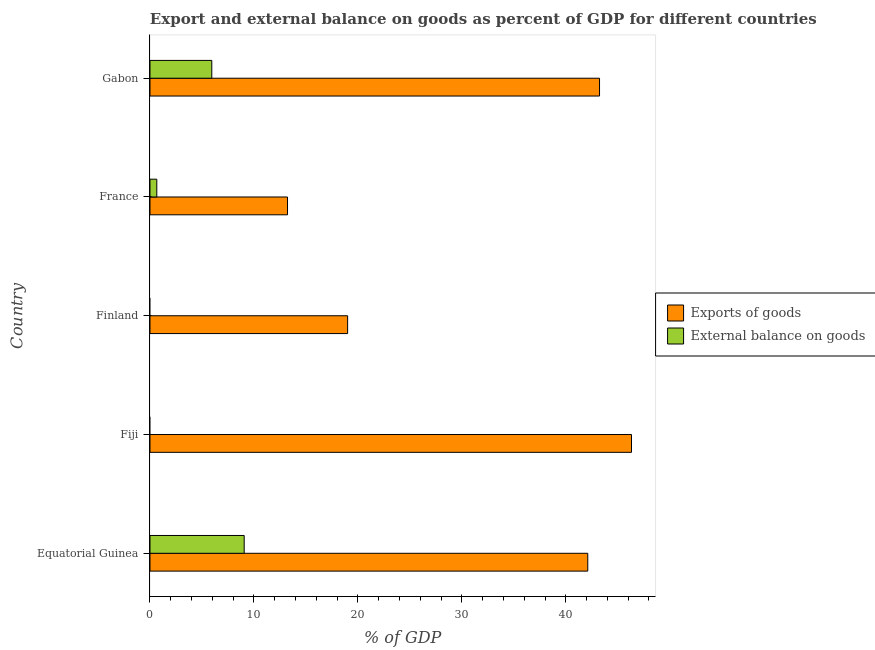How many different coloured bars are there?
Ensure brevity in your answer.  2. Are the number of bars per tick equal to the number of legend labels?
Make the answer very short. No. Are the number of bars on each tick of the Y-axis equal?
Ensure brevity in your answer.  No. What is the label of the 1st group of bars from the top?
Provide a short and direct response. Gabon. What is the export of goods as percentage of gdp in Equatorial Guinea?
Your answer should be very brief. 42.11. Across all countries, what is the maximum export of goods as percentage of gdp?
Give a very brief answer. 46.32. Across all countries, what is the minimum export of goods as percentage of gdp?
Your answer should be compact. 13.23. In which country was the export of goods as percentage of gdp maximum?
Make the answer very short. Fiji. What is the total export of goods as percentage of gdp in the graph?
Give a very brief answer. 163.91. What is the difference between the external balance on goods as percentage of gdp in Equatorial Guinea and that in France?
Keep it short and to the point. 8.41. What is the difference between the external balance on goods as percentage of gdp in Fiji and the export of goods as percentage of gdp in Finland?
Keep it short and to the point. -19.01. What is the average export of goods as percentage of gdp per country?
Provide a short and direct response. 32.78. What is the difference between the external balance on goods as percentage of gdp and export of goods as percentage of gdp in Equatorial Guinea?
Keep it short and to the point. -33.05. What is the ratio of the export of goods as percentage of gdp in Fiji to that in Gabon?
Ensure brevity in your answer.  1.07. What is the difference between the highest and the second highest export of goods as percentage of gdp?
Give a very brief answer. 3.08. What is the difference between the highest and the lowest external balance on goods as percentage of gdp?
Your answer should be compact. 9.06. In how many countries, is the external balance on goods as percentage of gdp greater than the average external balance on goods as percentage of gdp taken over all countries?
Provide a short and direct response. 2. Is the sum of the export of goods as percentage of gdp in Fiji and Finland greater than the maximum external balance on goods as percentage of gdp across all countries?
Give a very brief answer. Yes. How many bars are there?
Give a very brief answer. 8. Does the graph contain any zero values?
Make the answer very short. Yes. How are the legend labels stacked?
Offer a very short reply. Vertical. What is the title of the graph?
Offer a terse response. Export and external balance on goods as percent of GDP for different countries. What is the label or title of the X-axis?
Offer a very short reply. % of GDP. What is the % of GDP in Exports of goods in Equatorial Guinea?
Ensure brevity in your answer.  42.11. What is the % of GDP in External balance on goods in Equatorial Guinea?
Keep it short and to the point. 9.06. What is the % of GDP of Exports of goods in Fiji?
Make the answer very short. 46.32. What is the % of GDP in Exports of goods in Finland?
Ensure brevity in your answer.  19.01. What is the % of GDP in Exports of goods in France?
Keep it short and to the point. 13.23. What is the % of GDP of External balance on goods in France?
Offer a terse response. 0.66. What is the % of GDP of Exports of goods in Gabon?
Offer a terse response. 43.24. What is the % of GDP in External balance on goods in Gabon?
Offer a terse response. 5.95. Across all countries, what is the maximum % of GDP of Exports of goods?
Offer a very short reply. 46.32. Across all countries, what is the maximum % of GDP in External balance on goods?
Keep it short and to the point. 9.06. Across all countries, what is the minimum % of GDP in Exports of goods?
Provide a succinct answer. 13.23. What is the total % of GDP in Exports of goods in the graph?
Your answer should be compact. 163.91. What is the total % of GDP in External balance on goods in the graph?
Provide a succinct answer. 15.66. What is the difference between the % of GDP in Exports of goods in Equatorial Guinea and that in Fiji?
Offer a terse response. -4.21. What is the difference between the % of GDP in Exports of goods in Equatorial Guinea and that in Finland?
Make the answer very short. 23.1. What is the difference between the % of GDP in Exports of goods in Equatorial Guinea and that in France?
Your response must be concise. 28.88. What is the difference between the % of GDP of External balance on goods in Equatorial Guinea and that in France?
Make the answer very short. 8.41. What is the difference between the % of GDP of Exports of goods in Equatorial Guinea and that in Gabon?
Your response must be concise. -1.13. What is the difference between the % of GDP of External balance on goods in Equatorial Guinea and that in Gabon?
Provide a short and direct response. 3.11. What is the difference between the % of GDP of Exports of goods in Fiji and that in Finland?
Make the answer very short. 27.31. What is the difference between the % of GDP of Exports of goods in Fiji and that in France?
Keep it short and to the point. 33.09. What is the difference between the % of GDP of Exports of goods in Fiji and that in Gabon?
Keep it short and to the point. 3.08. What is the difference between the % of GDP of Exports of goods in Finland and that in France?
Give a very brief answer. 5.78. What is the difference between the % of GDP in Exports of goods in Finland and that in Gabon?
Offer a terse response. -24.23. What is the difference between the % of GDP of Exports of goods in France and that in Gabon?
Your answer should be compact. -30.01. What is the difference between the % of GDP of External balance on goods in France and that in Gabon?
Your response must be concise. -5.29. What is the difference between the % of GDP in Exports of goods in Equatorial Guinea and the % of GDP in External balance on goods in France?
Your answer should be very brief. 41.46. What is the difference between the % of GDP of Exports of goods in Equatorial Guinea and the % of GDP of External balance on goods in Gabon?
Offer a terse response. 36.17. What is the difference between the % of GDP of Exports of goods in Fiji and the % of GDP of External balance on goods in France?
Provide a succinct answer. 45.66. What is the difference between the % of GDP in Exports of goods in Fiji and the % of GDP in External balance on goods in Gabon?
Your answer should be compact. 40.37. What is the difference between the % of GDP of Exports of goods in Finland and the % of GDP of External balance on goods in France?
Your answer should be compact. 18.36. What is the difference between the % of GDP of Exports of goods in Finland and the % of GDP of External balance on goods in Gabon?
Make the answer very short. 13.07. What is the difference between the % of GDP of Exports of goods in France and the % of GDP of External balance on goods in Gabon?
Ensure brevity in your answer.  7.28. What is the average % of GDP in Exports of goods per country?
Make the answer very short. 32.78. What is the average % of GDP in External balance on goods per country?
Your answer should be compact. 3.13. What is the difference between the % of GDP of Exports of goods and % of GDP of External balance on goods in Equatorial Guinea?
Make the answer very short. 33.05. What is the difference between the % of GDP in Exports of goods and % of GDP in External balance on goods in France?
Make the answer very short. 12.57. What is the difference between the % of GDP in Exports of goods and % of GDP in External balance on goods in Gabon?
Offer a very short reply. 37.3. What is the ratio of the % of GDP of Exports of goods in Equatorial Guinea to that in Fiji?
Offer a terse response. 0.91. What is the ratio of the % of GDP of Exports of goods in Equatorial Guinea to that in Finland?
Offer a very short reply. 2.21. What is the ratio of the % of GDP in Exports of goods in Equatorial Guinea to that in France?
Offer a terse response. 3.18. What is the ratio of the % of GDP of External balance on goods in Equatorial Guinea to that in France?
Ensure brevity in your answer.  13.83. What is the ratio of the % of GDP of Exports of goods in Equatorial Guinea to that in Gabon?
Provide a short and direct response. 0.97. What is the ratio of the % of GDP of External balance on goods in Equatorial Guinea to that in Gabon?
Provide a short and direct response. 1.52. What is the ratio of the % of GDP of Exports of goods in Fiji to that in Finland?
Your answer should be compact. 2.44. What is the ratio of the % of GDP of Exports of goods in Fiji to that in France?
Keep it short and to the point. 3.5. What is the ratio of the % of GDP of Exports of goods in Fiji to that in Gabon?
Make the answer very short. 1.07. What is the ratio of the % of GDP of Exports of goods in Finland to that in France?
Ensure brevity in your answer.  1.44. What is the ratio of the % of GDP of Exports of goods in Finland to that in Gabon?
Offer a terse response. 0.44. What is the ratio of the % of GDP in Exports of goods in France to that in Gabon?
Your answer should be very brief. 0.31. What is the ratio of the % of GDP in External balance on goods in France to that in Gabon?
Offer a very short reply. 0.11. What is the difference between the highest and the second highest % of GDP in Exports of goods?
Your answer should be very brief. 3.08. What is the difference between the highest and the second highest % of GDP in External balance on goods?
Give a very brief answer. 3.11. What is the difference between the highest and the lowest % of GDP in Exports of goods?
Ensure brevity in your answer.  33.09. What is the difference between the highest and the lowest % of GDP in External balance on goods?
Your answer should be compact. 9.06. 